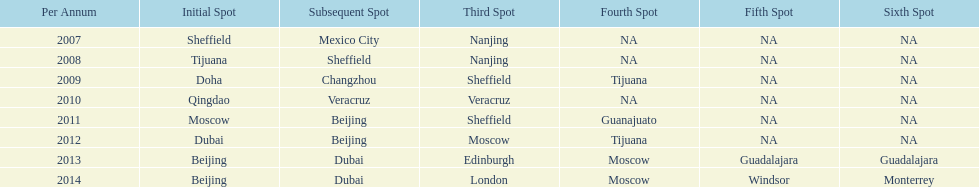Which is the only year that mexico is on a venue 2007. 